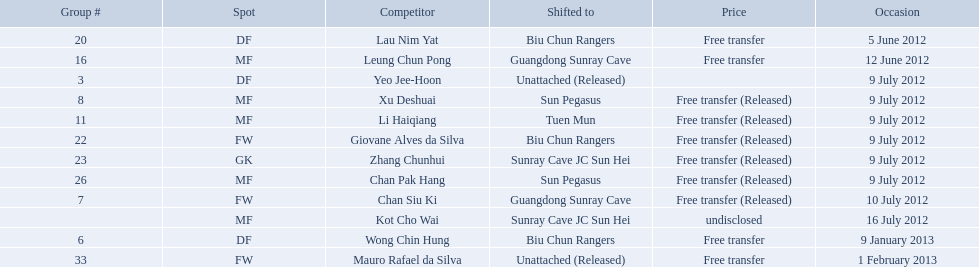Which players played during the 2012-13 south china aa season? Lau Nim Yat, Leung Chun Pong, Yeo Jee-Hoon, Xu Deshuai, Li Haiqiang, Giovane Alves da Silva, Zhang Chunhui, Chan Pak Hang, Chan Siu Ki, Kot Cho Wai, Wong Chin Hung, Mauro Rafael da Silva. Of these, which were free transfers that were not released? Lau Nim Yat, Leung Chun Pong, Wong Chin Hung, Mauro Rafael da Silva. Of these, which were in squad # 6? Wong Chin Hung. What was the date of his transfer? 9 January 2013. Which players are listed? Lau Nim Yat, Leung Chun Pong, Yeo Jee-Hoon, Xu Deshuai, Li Haiqiang, Giovane Alves da Silva, Zhang Chunhui, Chan Pak Hang, Chan Siu Ki, Kot Cho Wai, Wong Chin Hung, Mauro Rafael da Silva. Which dates were players transferred to the biu chun rangers? 5 June 2012, 9 July 2012, 9 January 2013. Of those which is the date for wong chin hung? 9 January 2013. 